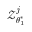<formula> <loc_0><loc_0><loc_500><loc_500>\mathcal { Z } _ { \theta _ { 1 } ^ { \ast } } ^ { j }</formula> 